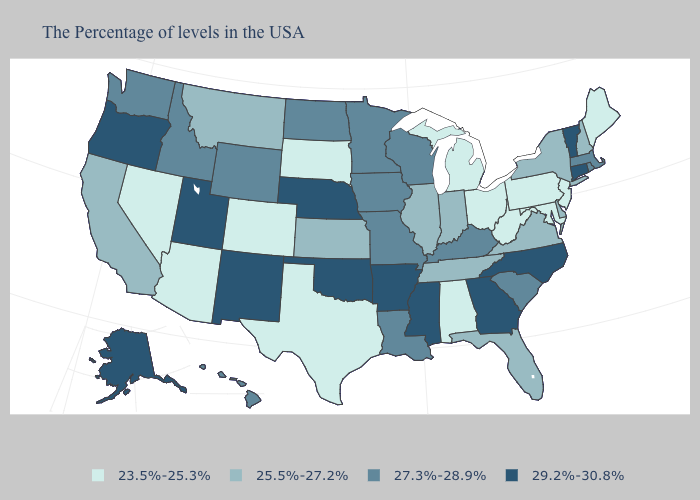Does Arkansas have the highest value in the South?
Be succinct. Yes. Among the states that border Iowa , which have the lowest value?
Quick response, please. South Dakota. What is the value of Wisconsin?
Short answer required. 27.3%-28.9%. Which states have the lowest value in the USA?
Quick response, please. Maine, New Jersey, Maryland, Pennsylvania, West Virginia, Ohio, Michigan, Alabama, Texas, South Dakota, Colorado, Arizona, Nevada. Among the states that border Texas , does Oklahoma have the lowest value?
Keep it brief. No. Name the states that have a value in the range 27.3%-28.9%?
Concise answer only. Massachusetts, Rhode Island, South Carolina, Kentucky, Wisconsin, Louisiana, Missouri, Minnesota, Iowa, North Dakota, Wyoming, Idaho, Washington, Hawaii. What is the value of Louisiana?
Answer briefly. 27.3%-28.9%. What is the value of Arizona?
Write a very short answer. 23.5%-25.3%. What is the value of Kentucky?
Keep it brief. 27.3%-28.9%. Among the states that border Louisiana , does Texas have the highest value?
Give a very brief answer. No. Is the legend a continuous bar?
Concise answer only. No. Does the first symbol in the legend represent the smallest category?
Keep it brief. Yes. Name the states that have a value in the range 25.5%-27.2%?
Concise answer only. New Hampshire, New York, Delaware, Virginia, Florida, Indiana, Tennessee, Illinois, Kansas, Montana, California. What is the value of North Carolina?
Concise answer only. 29.2%-30.8%. Which states have the lowest value in the USA?
Concise answer only. Maine, New Jersey, Maryland, Pennsylvania, West Virginia, Ohio, Michigan, Alabama, Texas, South Dakota, Colorado, Arizona, Nevada. 